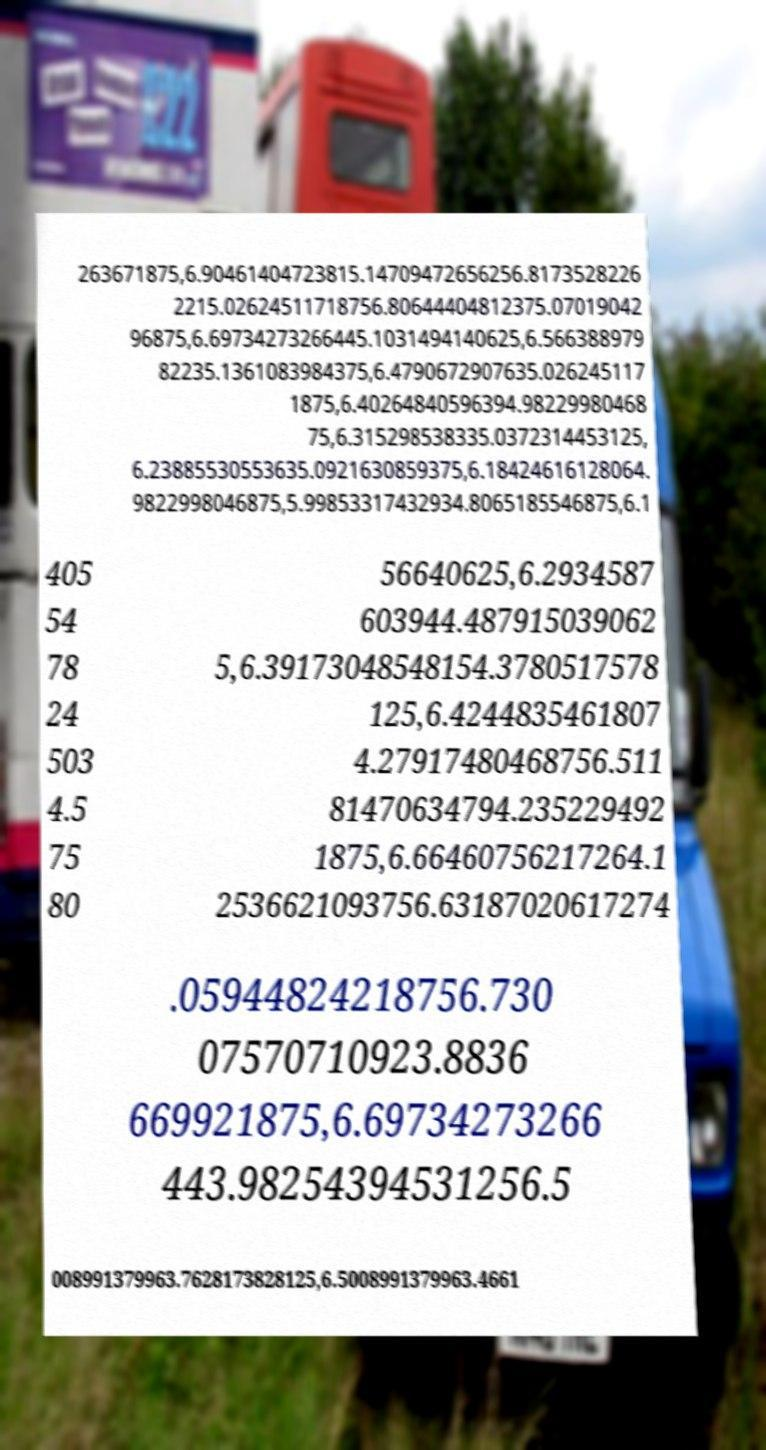Please identify and transcribe the text found in this image. 263671875,6.90461404723815.14709472656256.8173528226 2215.02624511718756.80644404812375.07019042 96875,6.69734273266445.1031494140625,6.566388979 82235.1361083984375,6.4790672907635.026245117 1875,6.40264840596394.98229980468 75,6.315298538335.0372314453125, 6.23885530553635.0921630859375,6.18424616128064. 9822998046875,5.99853317432934.8065185546875,6.1 405 54 78 24 503 4.5 75 80 56640625,6.2934587 603944.487915039062 5,6.39173048548154.3780517578 125,6.4244835461807 4.27917480468756.511 81470634794.235229492 1875,6.66460756217264.1 2536621093756.63187020617274 .05944824218756.730 07570710923.8836 669921875,6.69734273266 443.98254394531256.5 008991379963.7628173828125,6.5008991379963.4661 